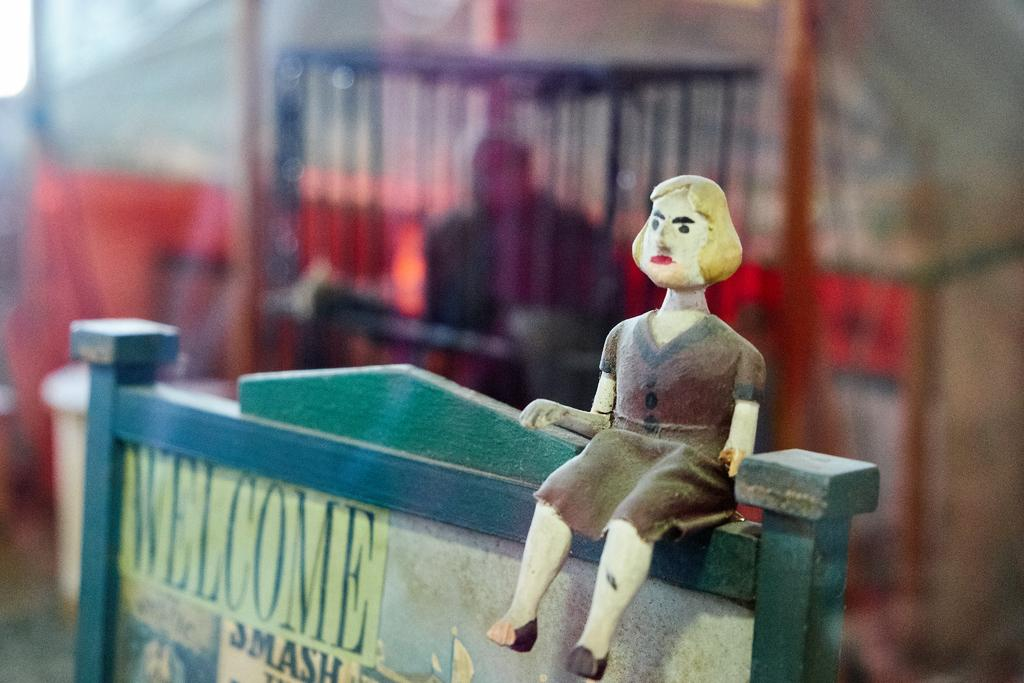What object is present in the image that is not a part of the background? There is a toy in the image. How is the toy positioned in the image? The toy is placed on a board. What can be found on the board along with the toy? There is text on the board. Can you describe the appearance of the background in the image? The background of the image is slightly blurred. What additional object can be seen in the background? There is a cage visible in the background. How does the duck rest on the toy in the image? There is no duck present in the image, so it cannot rest on the toy. 